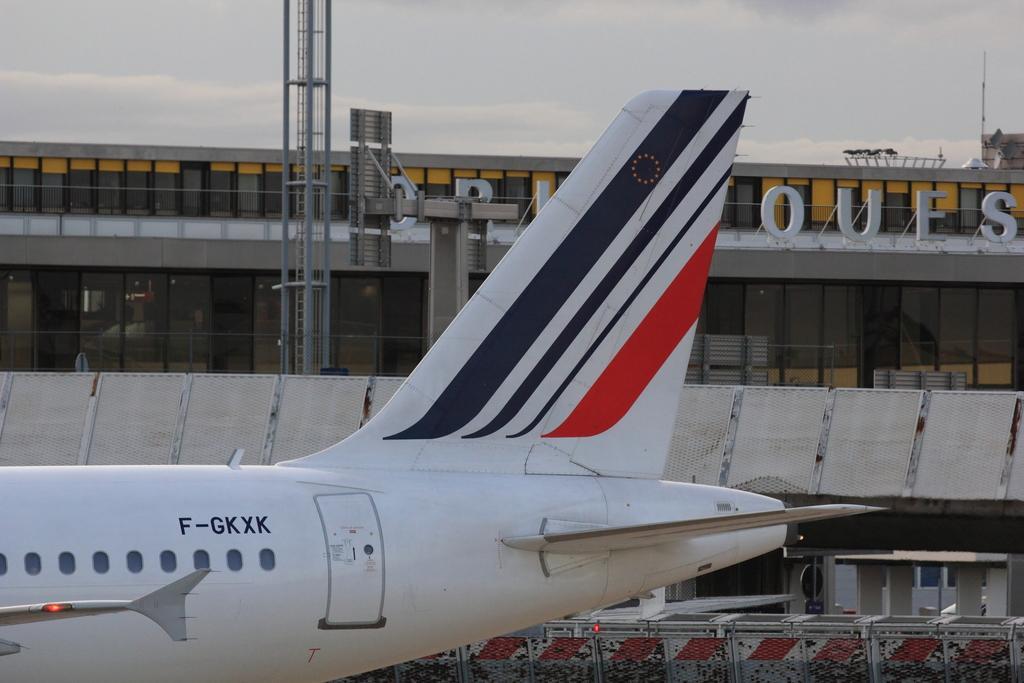Can you describe this image briefly? This image might be clicked in an airport. There is sky at the top. There is an airplane at the bottom. It has wings and windows. 